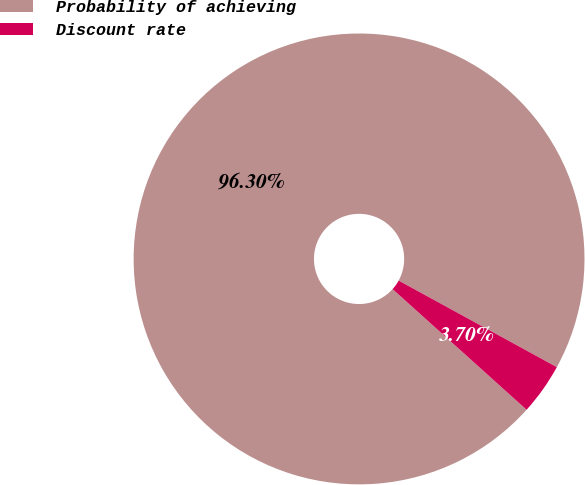Convert chart. <chart><loc_0><loc_0><loc_500><loc_500><pie_chart><fcel>Probability of achieving<fcel>Discount rate<nl><fcel>96.3%<fcel>3.7%<nl></chart> 